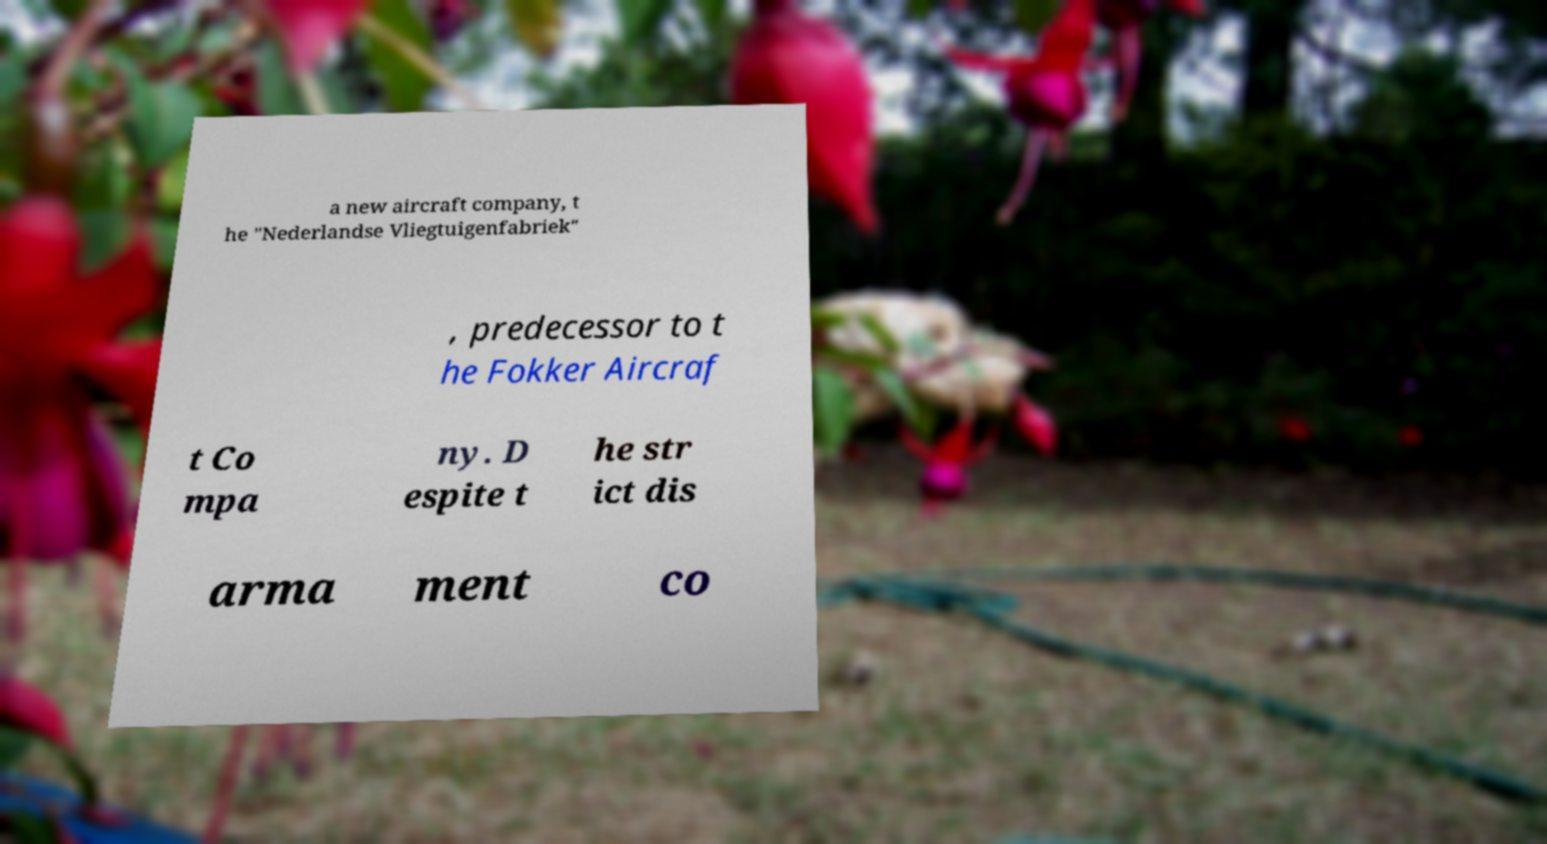I need the written content from this picture converted into text. Can you do that? a new aircraft company, t he "Nederlandse Vliegtuigenfabriek" , predecessor to t he Fokker Aircraf t Co mpa ny. D espite t he str ict dis arma ment co 